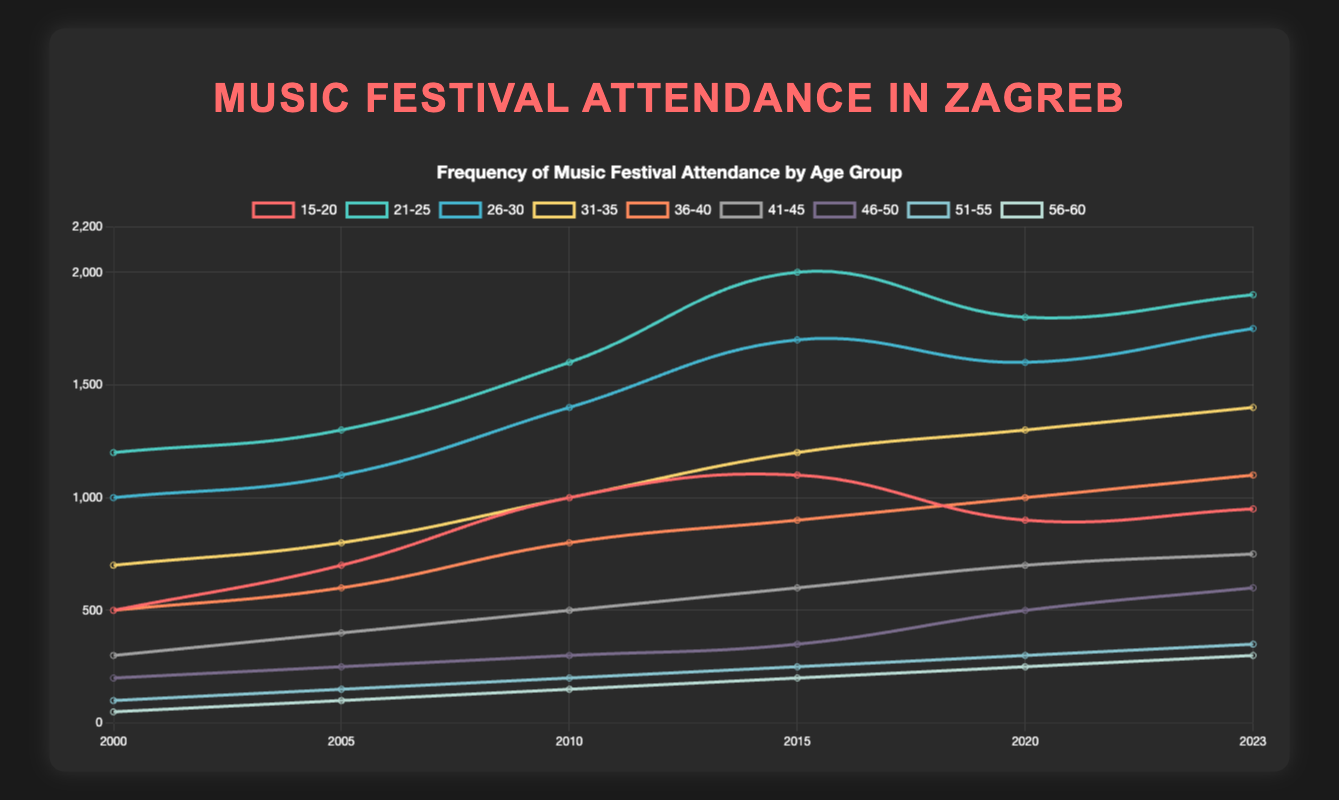Which age group has shown the highest increase in attendance from 2000 to 2023? Track the increase for each age group by subtracting their attendance in 2000 from their attendance in 2023. Age group 21-25 has the highest increase: 1900 - 1200 = 700.
Answer: Age 21-25 Which age group had the lowest attendance in 2023? Observe the attendance values for each age group in the year 2023. The 56-60 age group had the lowest attendance with 300.
Answer: Age 56-60 How did attendance for the age group 31-35 change from 2015 to 2020? Compare the attendance in 2015 and 2020 for the 31-35 age group. The attendance increased from 1200 in 2015 to 1300 in 2020. Difference: 1300 - 1200 = 100.
Answer: Increase by 100 Which age group had the largest decline in attendance from 2015 to 2020? Calculate the difference between attendance in 2015 and 2020 for each age group. The age group 15-20 had the largest decline: 1100 - 900 = -200.
Answer: Age 15-20 Which age group saw a consistent increase in attendance every year? Check the trend for each age group from 2000 to 2023 for constant increase. The age groups 41-45, 46-50, 51-55, and 56-60 show consistent increase in attendance.
Answer: Ages 41-45, 46-50, 51-55, and 56-60 In which year did the age group 21-25 reach its highest attendance? Observe the attendance values for the age group 21-25 over the years. The highest attendance for this age group was 2000 in the year 2015.
Answer: 2015 Which age group had the smallest increase in attendance between 2000 and 2023? Calculate the increase in attendance from 2000 to 2023 for each age group. The age group 56-60 had the smallest increase: 300 - 50 = 250.
Answer: Age 56-60 How many total attendees were at music festivals in 2023 across all age groups? Sum the attendance numbers for all age groups in the year 2023. Total: 950 + 1900 + 1750 + 1400 + 1100 + 750 + 600 + 350 + 300 = 9100.
Answer: 9100 Which year saw the most attendees from the 46-50 age group? Compare the attendance values for the 46-50 age group across different years. The highest attendance was recorded in 2023 with 600 attendees.
Answer: 2023 Compare the attendance trend between the age groups 26-30 and 36-40. Who had a more significant growth? Compute the change in attendance for both age groups from 2000 to 2023. Age 26-30's increase: 1750 - 1000 = 750. Age 36-40's increase: 1100 - 500 = 600. The age group 26-30 had a more significant growth.
Answer: Age 26-30 